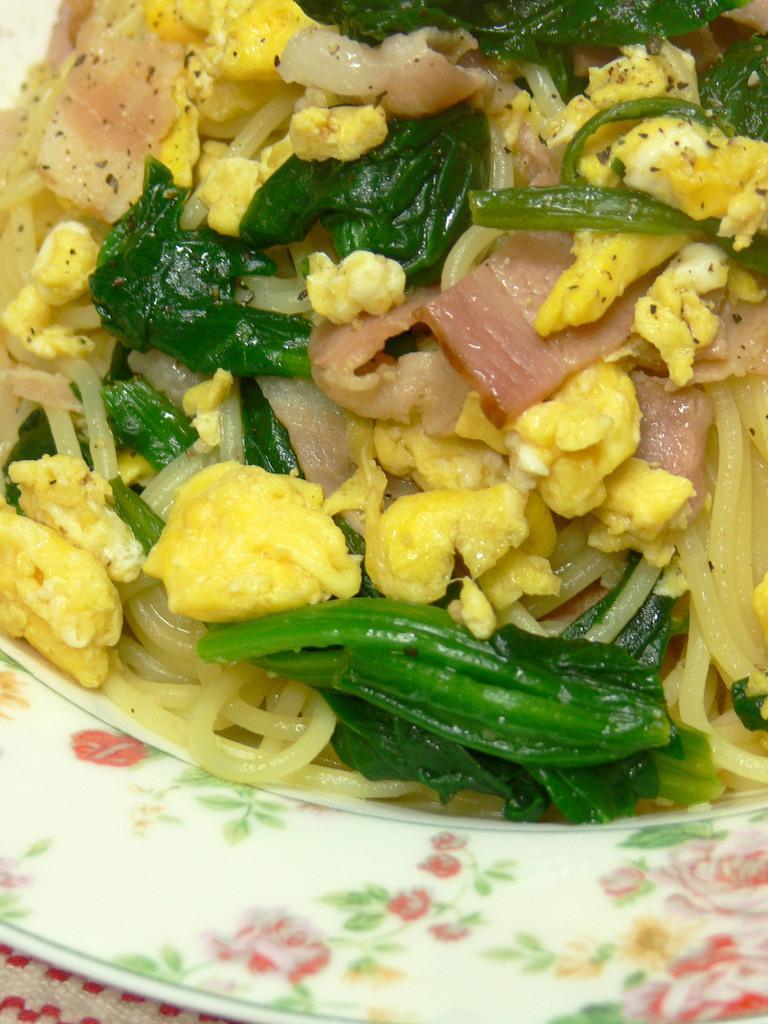Describe this image in one or two sentences. In this picture we can observe some food places in the white color plate. The food is in yellow and green color. There is a design on the white color plate. 